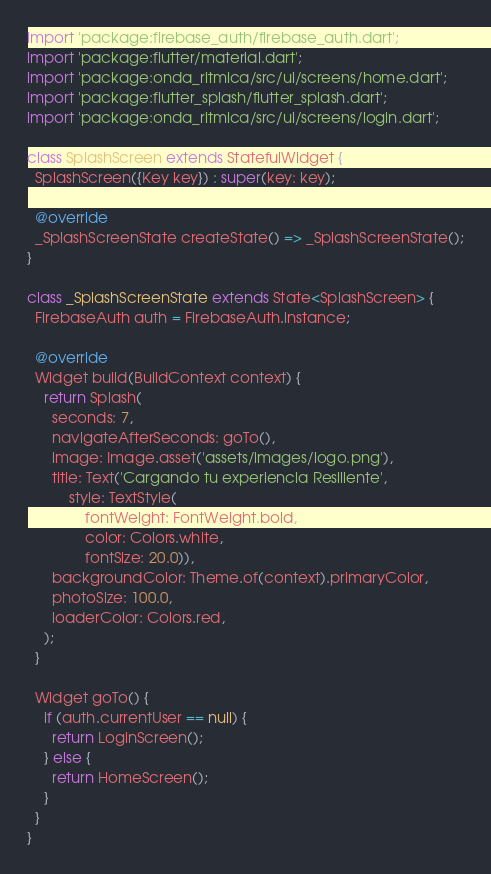<code> <loc_0><loc_0><loc_500><loc_500><_Dart_>import 'package:firebase_auth/firebase_auth.dart';
import 'package:flutter/material.dart';
import 'package:onda_ritmica/src/ui/screens/home.dart';
import 'package:flutter_splash/flutter_splash.dart';
import 'package:onda_ritmica/src/ui/screens/login.dart';

class SplashScreen extends StatefulWidget {
  SplashScreen({Key key}) : super(key: key);

  @override
  _SplashScreenState createState() => _SplashScreenState();
}

class _SplashScreenState extends State<SplashScreen> {
  FirebaseAuth auth = FirebaseAuth.instance;

  @override
  Widget build(BuildContext context) {
    return Splash(
      seconds: 7,
      navigateAfterSeconds: goTo(),
      image: Image.asset('assets/images/logo.png'),
      title: Text('Cargando tu experiencia Resiliente',
          style: TextStyle(
              fontWeight: FontWeight.bold,
              color: Colors.white,
              fontSize: 20.0)),
      backgroundColor: Theme.of(context).primaryColor,
      photoSize: 100.0,
      loaderColor: Colors.red,
    );
  }

  Widget goTo() {
    if (auth.currentUser == null) {
      return LoginScreen();
    } else {
      return HomeScreen();
    }
  }
}
</code> 